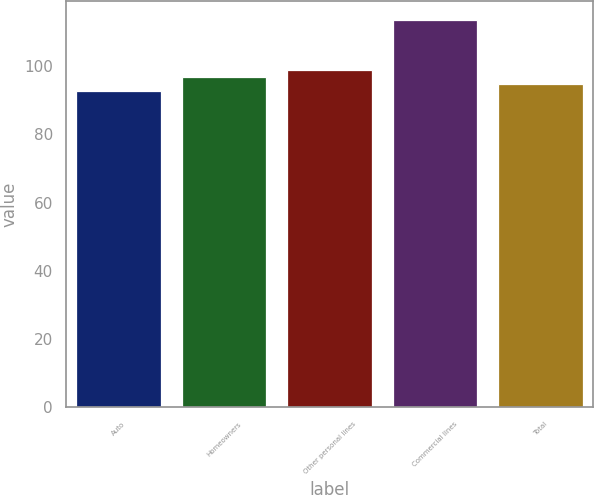Convert chart. <chart><loc_0><loc_0><loc_500><loc_500><bar_chart><fcel>Auto<fcel>Homeowners<fcel>Other personal lines<fcel>Commercial lines<fcel>Total<nl><fcel>92.7<fcel>96.82<fcel>98.88<fcel>113.3<fcel>94.76<nl></chart> 